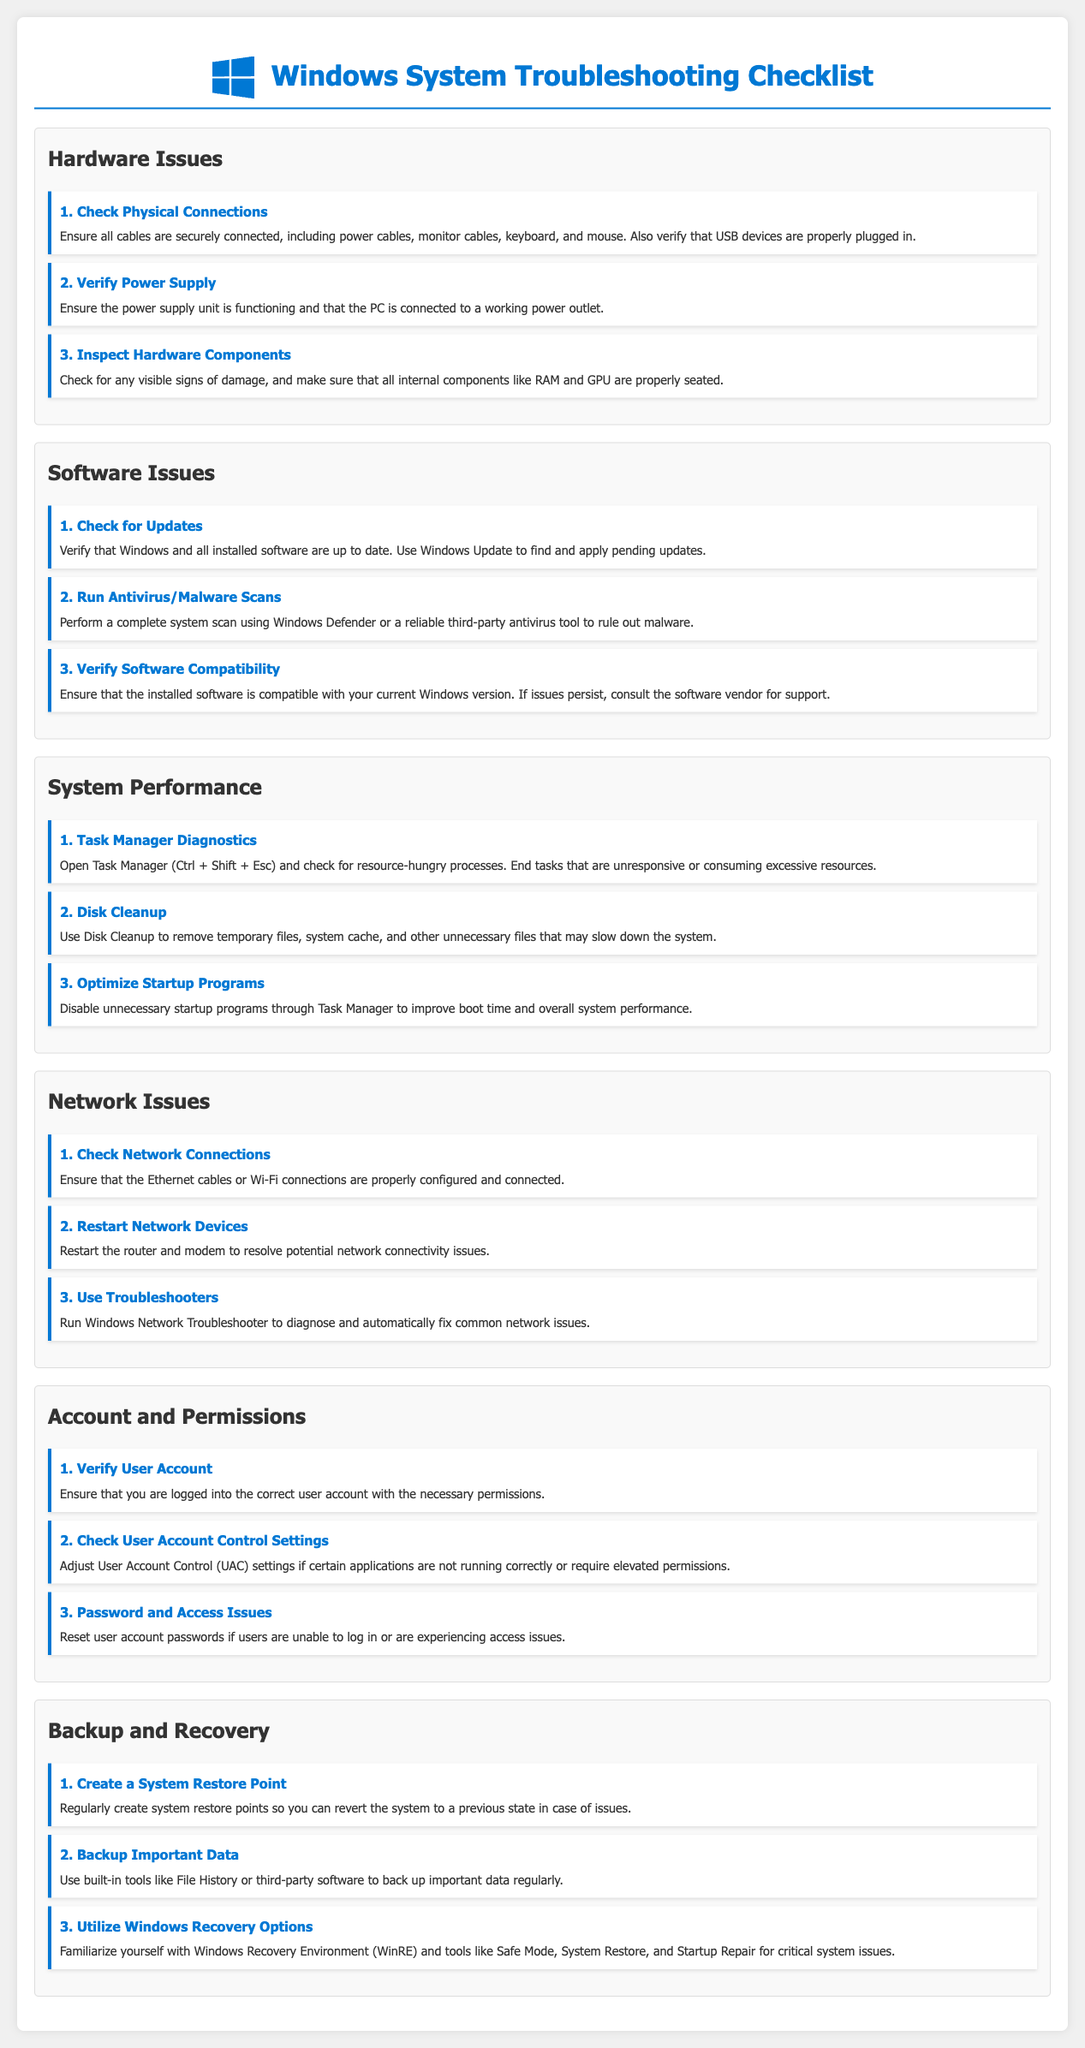what is the first item in the Hardware Issues section? The first item is "Check Physical Connections," which is listed under the Hardware Issues section of the document.
Answer: Check Physical Connections how many items are listed under Software Issues? The Software Issues section contains three items according to the document structure.
Answer: 3 what should you do if malware is suspected? The checklist advises performing a complete system scan using Windows Defender or a reliable third-party antivirus tool.
Answer: Run Antivirus/Malware Scans what is recommended for improving boot time? Disabling unnecessary startup programs is recommended to enhance boot time and overall system performance.
Answer: Optimize Startup Programs how can you create a backup of important data? You can use built-in tools like File History or third-party software to back up important data regularly.
Answer: Backup Important Data 